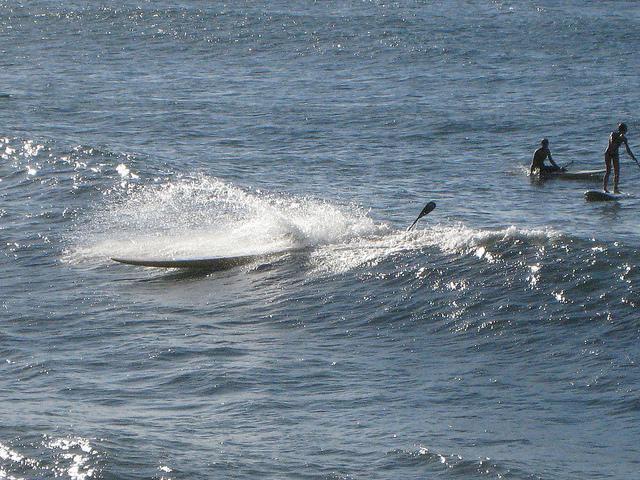What is below the paddle shown here?
Select the correct answer and articulate reasoning with the following format: 'Answer: answer
Rationale: rationale.'
Options: Whale, person, dolphin, land shark. Answer: person.
Rationale: The person below the paddle is likely a human submerged in water. 